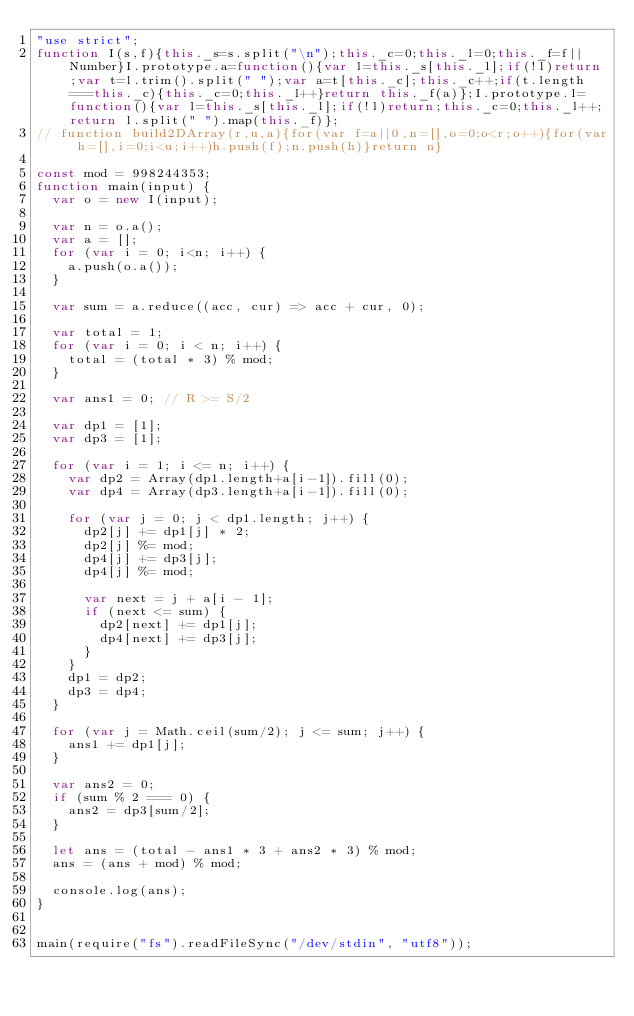Convert code to text. <code><loc_0><loc_0><loc_500><loc_500><_JavaScript_>"use strict";
function I(s,f){this._s=s.split("\n");this._c=0;this._l=0;this._f=f||Number}I.prototype.a=function(){var l=this._s[this._l];if(!l)return;var t=l.trim().split(" ");var a=t[this._c];this._c++;if(t.length===this._c){this._c=0;this._l++}return this._f(a)};I.prototype.l=function(){var l=this._s[this._l];if(!l)return;this._c=0;this._l++;return l.split(" ").map(this._f)};
// function build2DArray(r,u,a){for(var f=a||0,n=[],o=0;o<r;o++){for(var h=[],i=0;i<u;i++)h.push(f);n.push(h)}return n}
 
const mod = 998244353;
function main(input) {
  var o = new I(input);
 
  var n = o.a();
  var a = [];
  for (var i = 0; i<n; i++) {
    a.push(o.a());
  }
 
  var sum = a.reduce((acc, cur) => acc + cur, 0);
 
  var total = 1;
  for (var i = 0; i < n; i++) {
    total = (total * 3) % mod;
  }
 
  var ans1 = 0; // R >= S/2

  var dp1 = [1];
  var dp3 = [1];
 
  for (var i = 1; i <= n; i++) {
    var dp2 = Array(dp1.length+a[i-1]).fill(0);
    var dp4 = Array(dp3.length+a[i-1]).fill(0);

    for (var j = 0; j < dp1.length; j++) {
      dp2[j] += dp1[j] * 2;
      dp2[j] %= mod;
      dp4[j] += dp3[j];
      dp4[j] %= mod;

      var next = j + a[i - 1];
      if (next <= sum) {
        dp2[next] += dp1[j];
        dp4[next] += dp3[j];
      }
    }
    dp1 = dp2;
    dp3 = dp4;
  }

  for (var j = Math.ceil(sum/2); j <= sum; j++) {
    ans1 += dp1[j];
  }
 
  var ans2 = 0;
  if (sum % 2 === 0) {
    ans2 = dp3[sum/2];
  }
 
  let ans = (total - ans1 * 3 + ans2 * 3) % mod;
  ans = (ans + mod) % mod;
 
  console.log(ans);
}
 
 
main(require("fs").readFileSync("/dev/stdin", "utf8"));</code> 